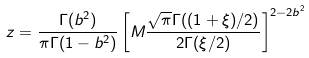<formula> <loc_0><loc_0><loc_500><loc_500>z = \frac { \Gamma ( b ^ { 2 } ) } { \pi \Gamma ( 1 - b ^ { 2 } ) } \left [ M \frac { \sqrt { \pi } \Gamma ( ( 1 + \xi ) / 2 ) } { 2 \Gamma ( \xi / 2 ) } \right ] ^ { 2 - 2 b ^ { 2 } }</formula> 